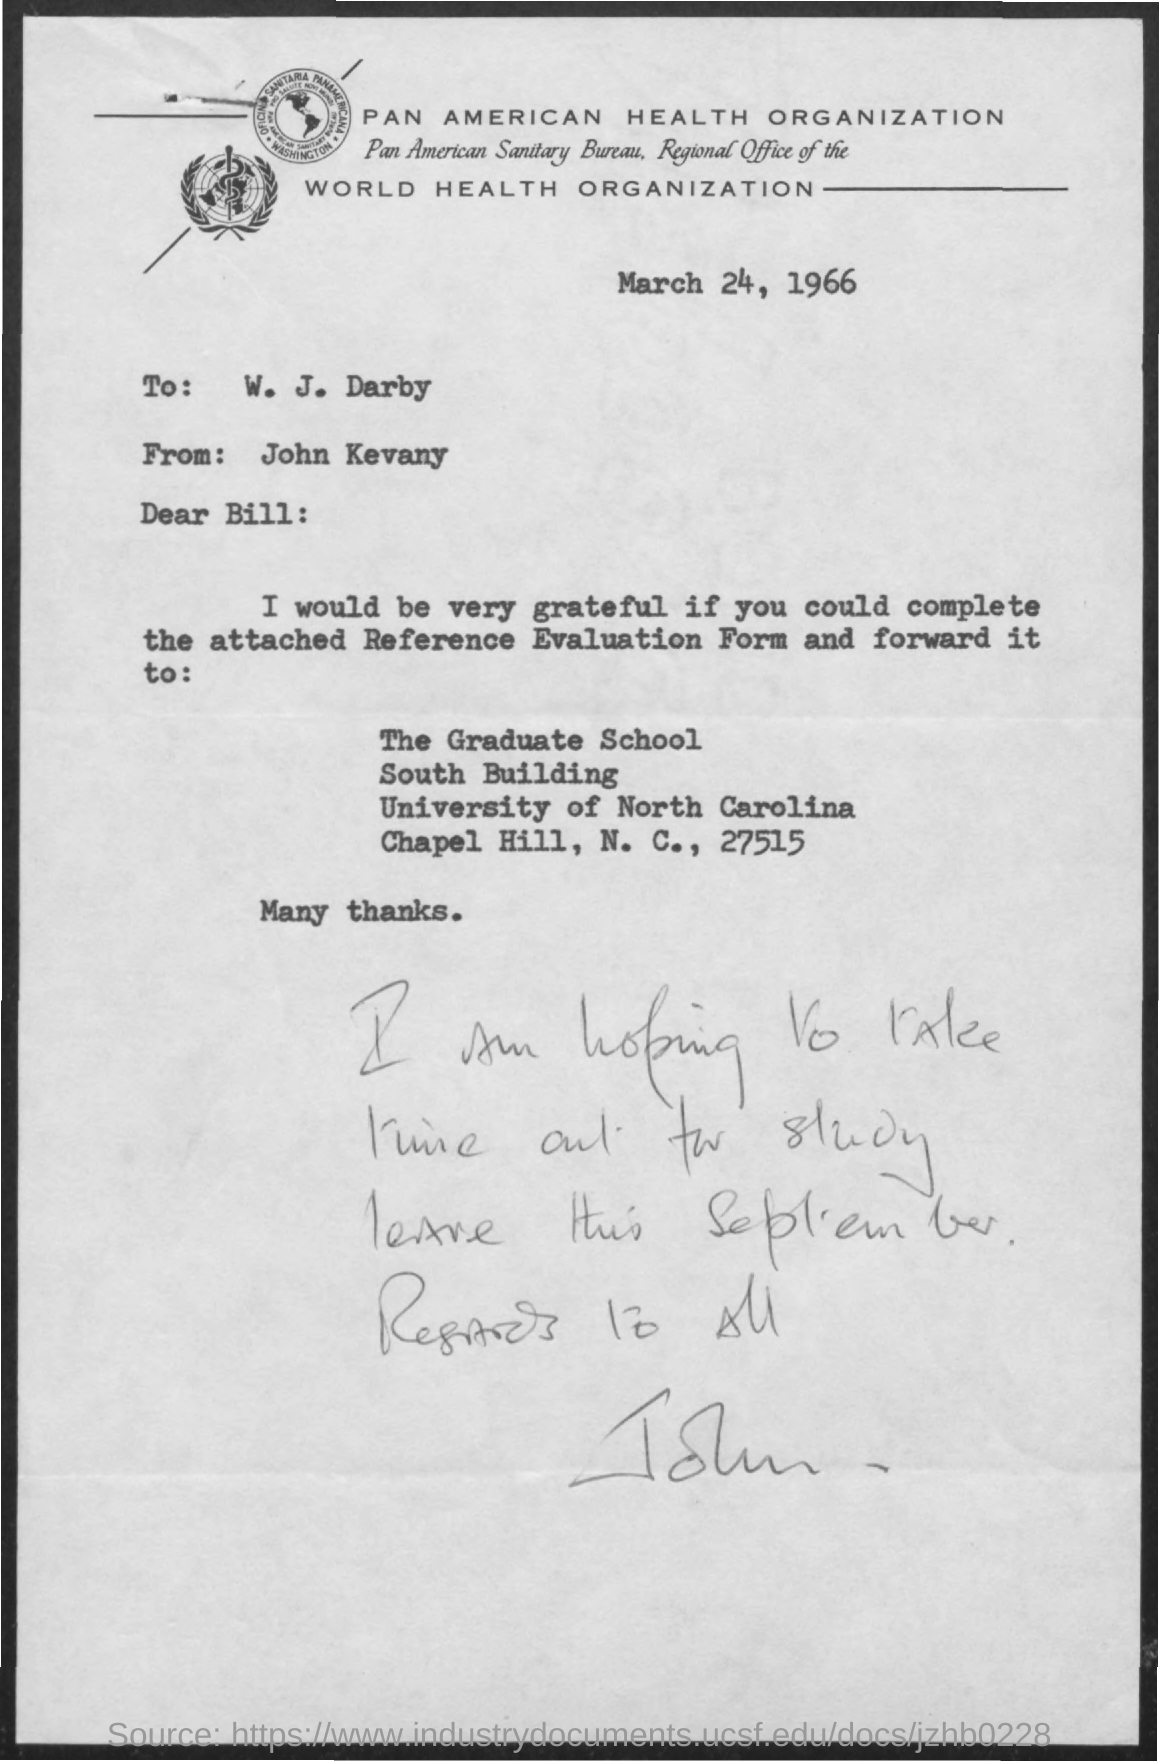Whic form is attached with this letter?
Your answer should be compact. Reference Evaluation Form. Who is the sender of this letter?
Make the answer very short. John Kevany. Who is the addressee of this letter?
Your answer should be very brief. W. j. darby. What is the letter dated?
Provide a short and direct response. March 24, 1966. 